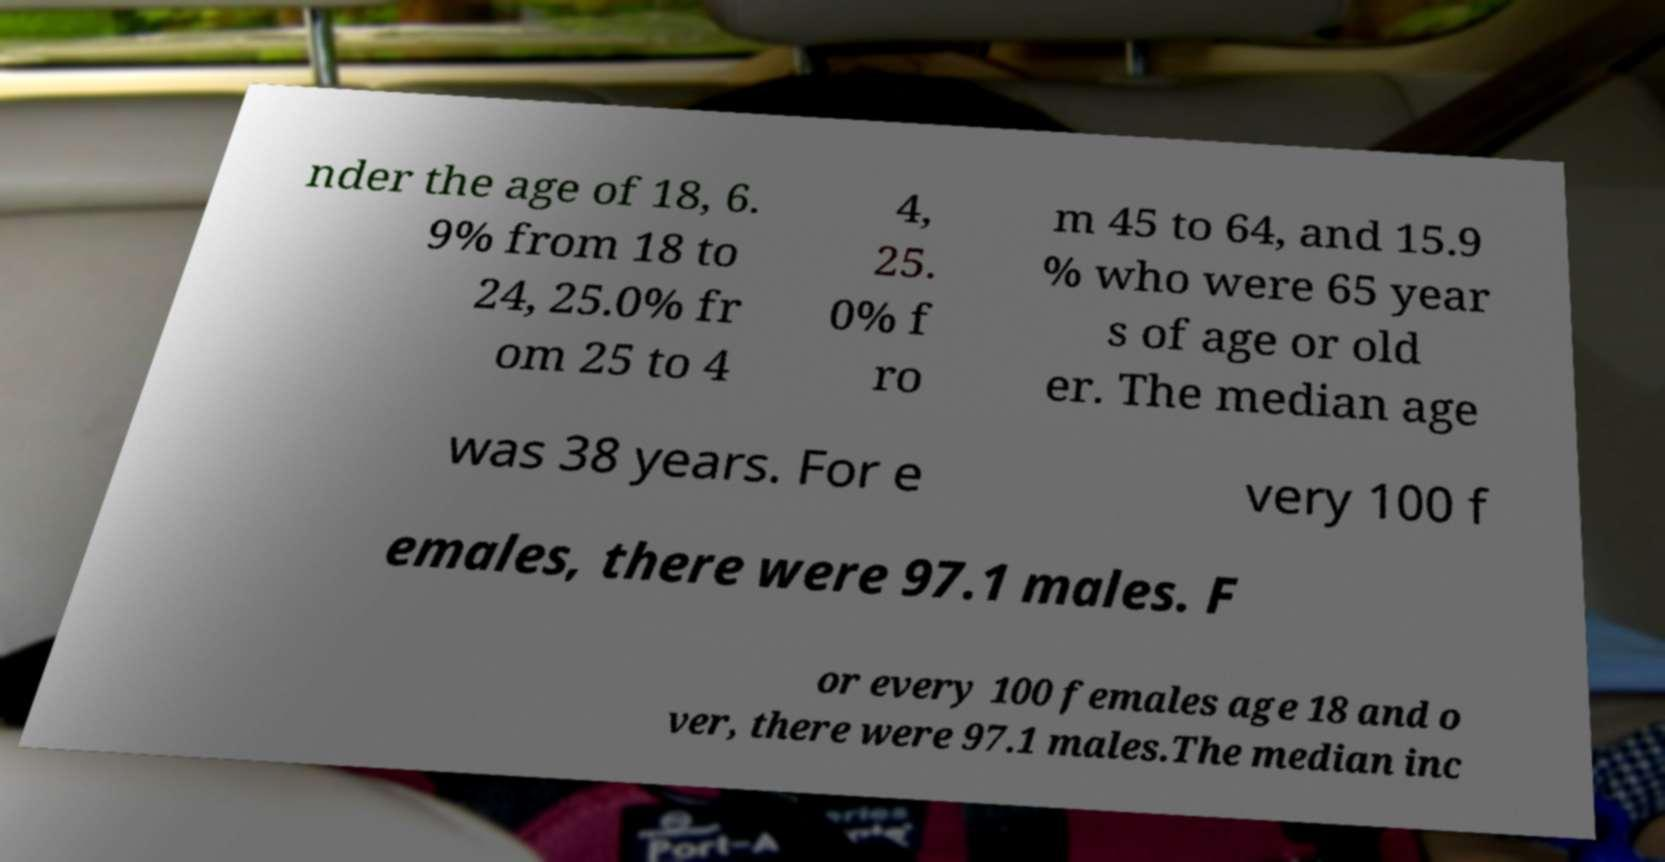Please identify and transcribe the text found in this image. nder the age of 18, 6. 9% from 18 to 24, 25.0% fr om 25 to 4 4, 25. 0% f ro m 45 to 64, and 15.9 % who were 65 year s of age or old er. The median age was 38 years. For e very 100 f emales, there were 97.1 males. F or every 100 females age 18 and o ver, there were 97.1 males.The median inc 